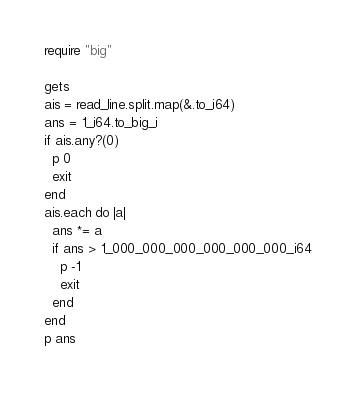Convert code to text. <code><loc_0><loc_0><loc_500><loc_500><_Crystal_>require "big"

gets
ais = read_line.split.map(&.to_i64)
ans = 1_i64.to_big_i
if ais.any?(0)
  p 0
  exit
end
ais.each do |a|
  ans *= a
  if ans > 1_000_000_000_000_000_000_i64
    p -1
    exit
  end
end
p ans</code> 